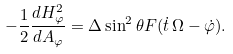<formula> <loc_0><loc_0><loc_500><loc_500>- \frac { 1 } { 2 } \frac { d H _ { \varphi } ^ { 2 } } { d A _ { \varphi } } = \Delta \sin ^ { 2 } \theta F ( \dot { t } \, \Omega - \dot { \varphi } ) .</formula> 